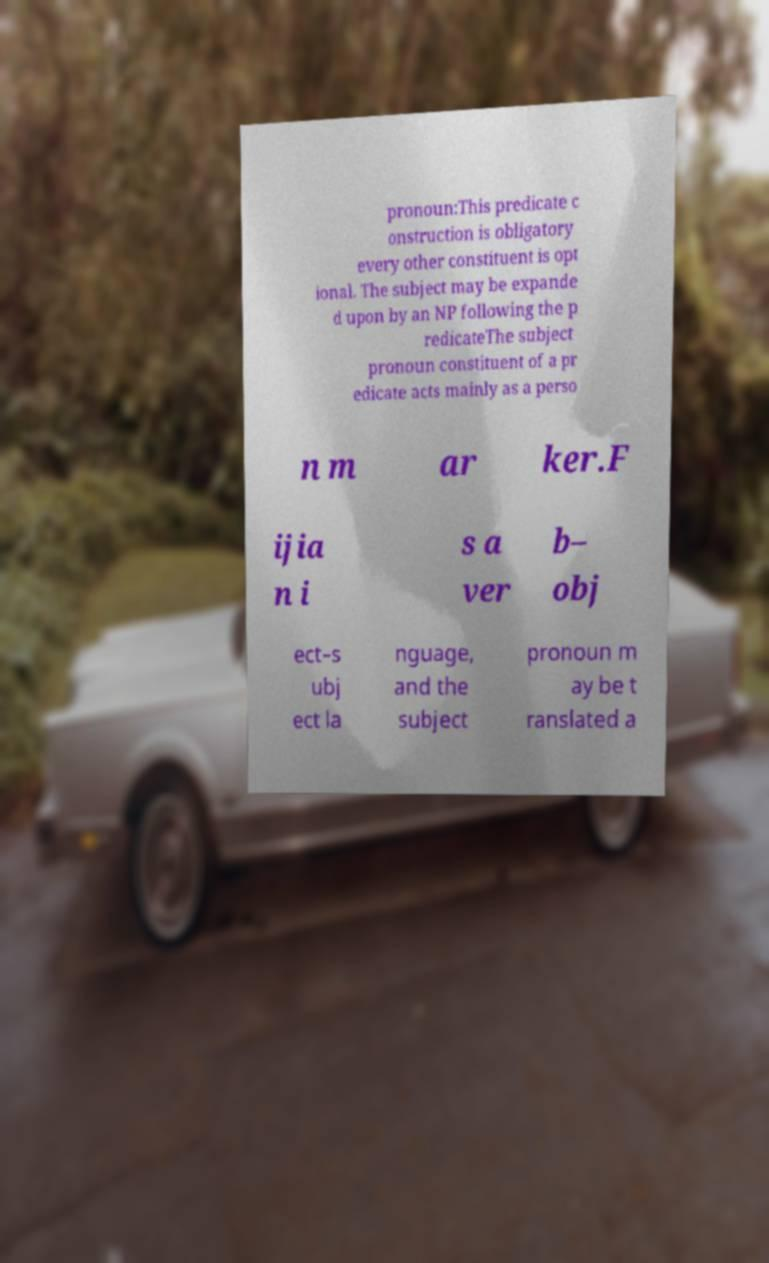There's text embedded in this image that I need extracted. Can you transcribe it verbatim? pronoun:This predicate c onstruction is obligatory every other constituent is opt ional. The subject may be expande d upon by an NP following the p redicateThe subject pronoun constituent of a pr edicate acts mainly as a perso n m ar ker.F ijia n i s a ver b– obj ect–s ubj ect la nguage, and the subject pronoun m ay be t ranslated a 